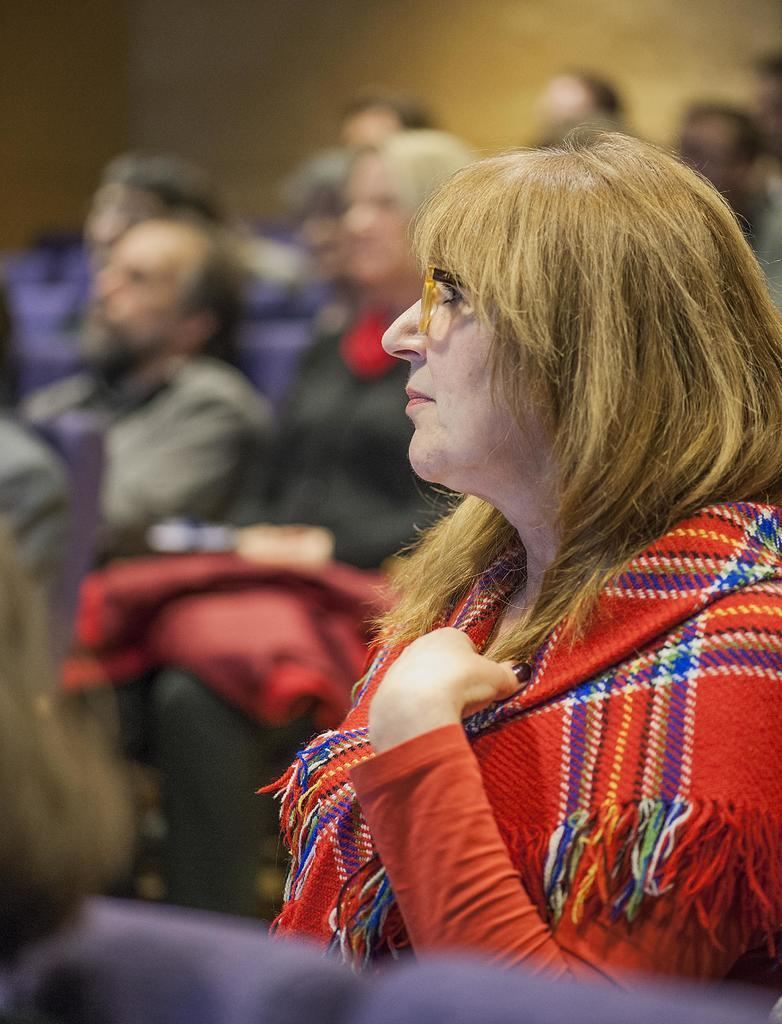What is the woman in the image doing? The woman is sitting in the image. What can be seen on the woman's face? The woman is wearing spectacles. Can you describe the people in the background of the image? The people in the background are visible but blurry. What type of furniture is the woman using to order her route? There is no furniture or route mentioned in the image, and the woman is not ordering anything. 